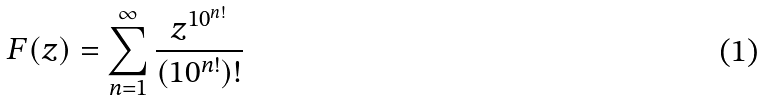Convert formula to latex. <formula><loc_0><loc_0><loc_500><loc_500>F ( z ) = \sum _ { n = 1 } ^ { \infty } \frac { z ^ { 1 0 ^ { n ! } } } { ( 1 0 ^ { n ! } ) ! }</formula> 